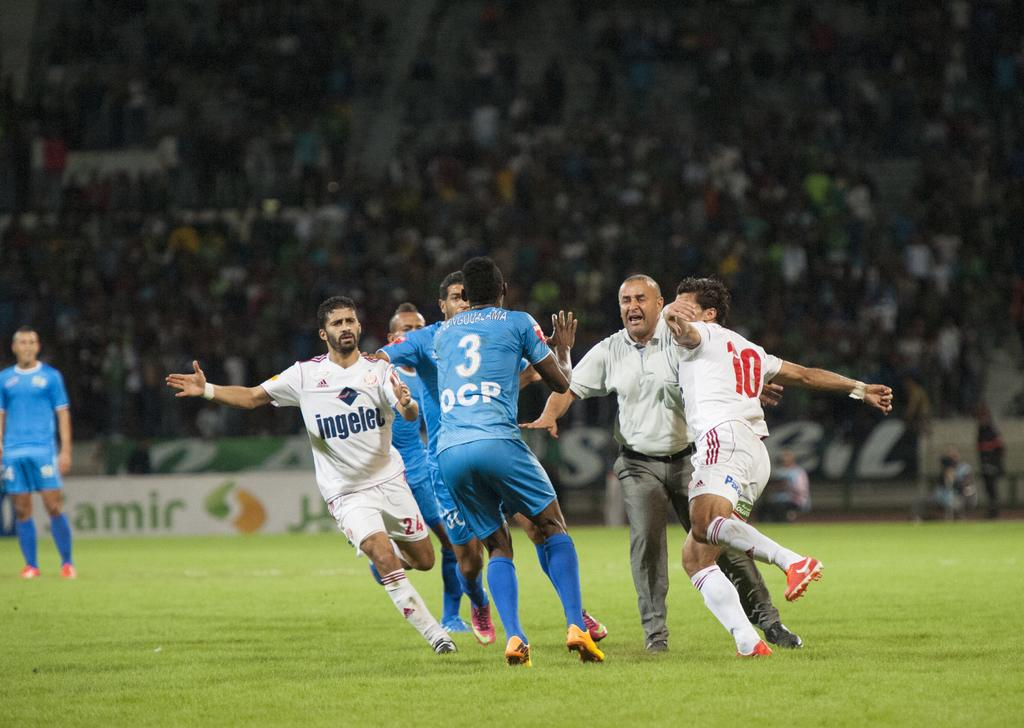<image>
Render a clear and concise summary of the photo. A group of soccer players with uniforms that say ingeles are about to fight as the referee tries to break it up. 